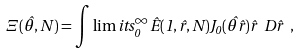<formula> <loc_0><loc_0><loc_500><loc_500>\Xi ( \hat { \theta } , N ) = \int \lim i t s ^ { \infty } _ { 0 } \hat { E } ( 1 , \hat { r } , N ) J _ { 0 } ( \hat { \theta } \hat { r } ) \hat { r } \ D \hat { r } \ ,</formula> 